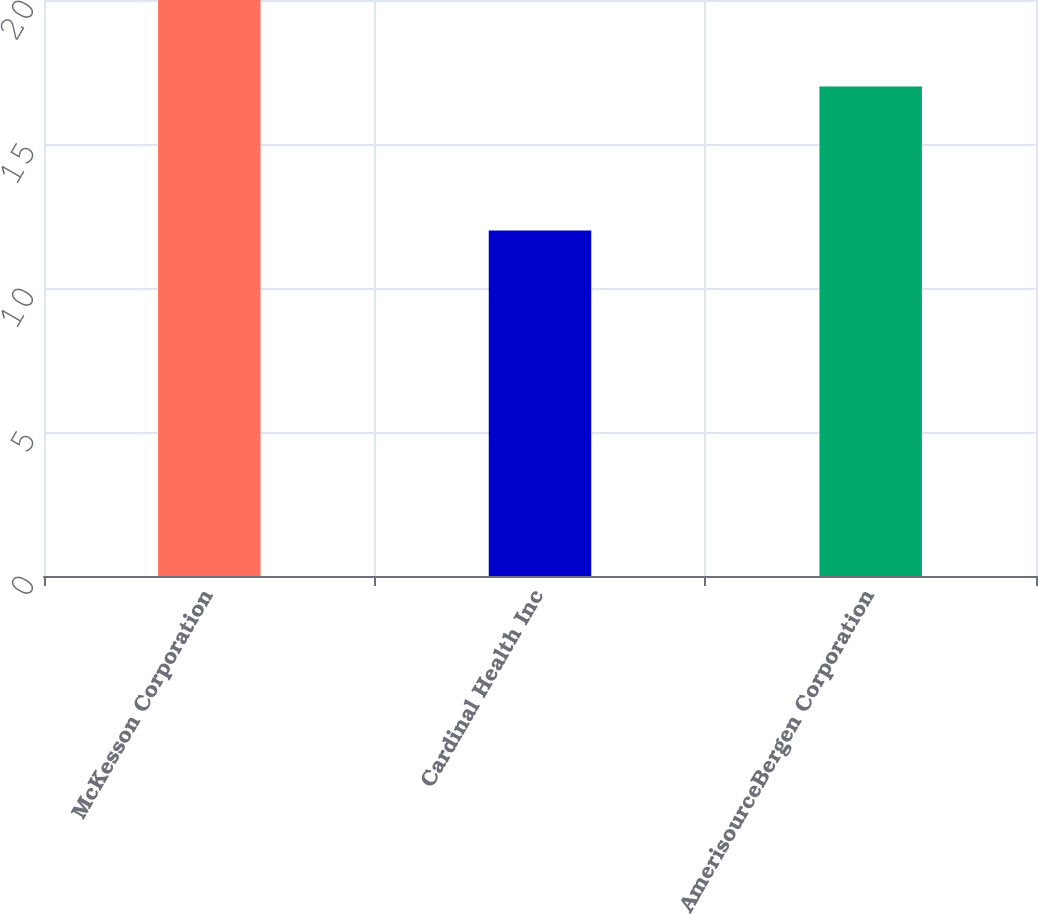<chart> <loc_0><loc_0><loc_500><loc_500><bar_chart><fcel>McKesson Corporation<fcel>Cardinal Health Inc<fcel>AmerisourceBergen Corporation<nl><fcel>20<fcel>12<fcel>17<nl></chart> 